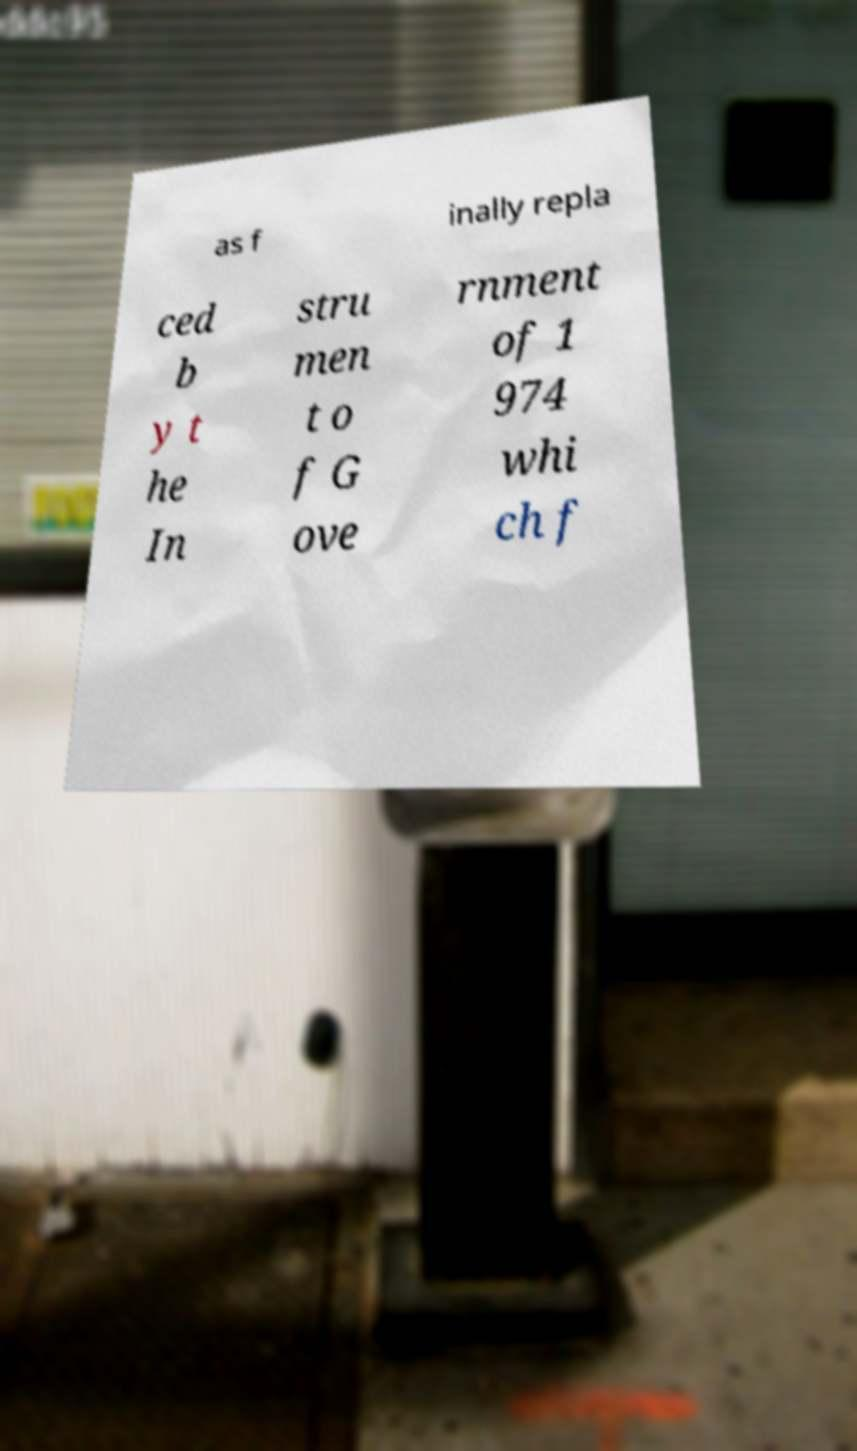For documentation purposes, I need the text within this image transcribed. Could you provide that? as f inally repla ced b y t he In stru men t o f G ove rnment of 1 974 whi ch f 